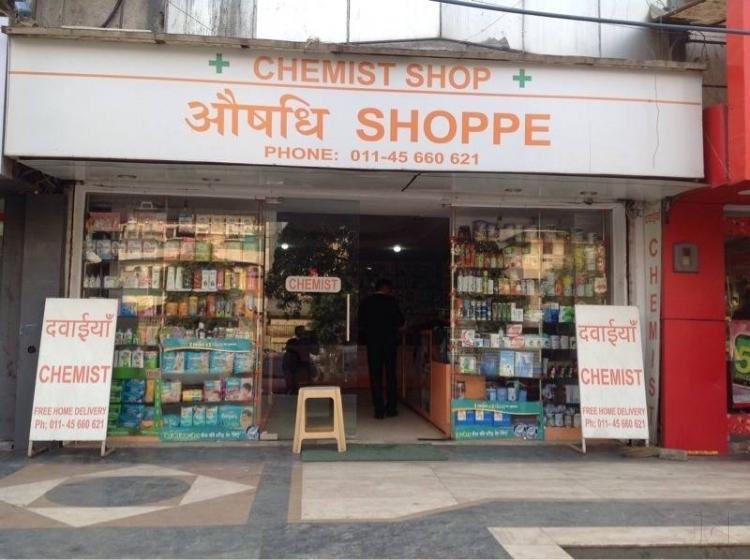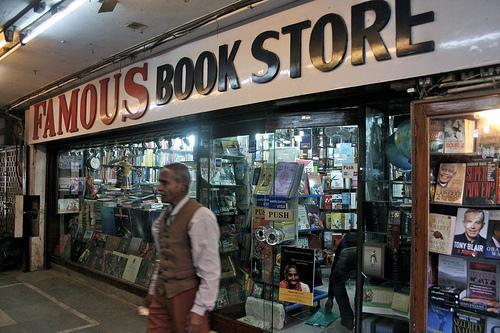The first image is the image on the left, the second image is the image on the right. Given the left and right images, does the statement "An image shows one man in a buttoned vest standing in the front area of a book store." hold true? Answer yes or no. Yes. The first image is the image on the left, the second image is the image on the right. Examine the images to the left and right. Is the description "Each of the images features the outside of a store." accurate? Answer yes or no. Yes. 